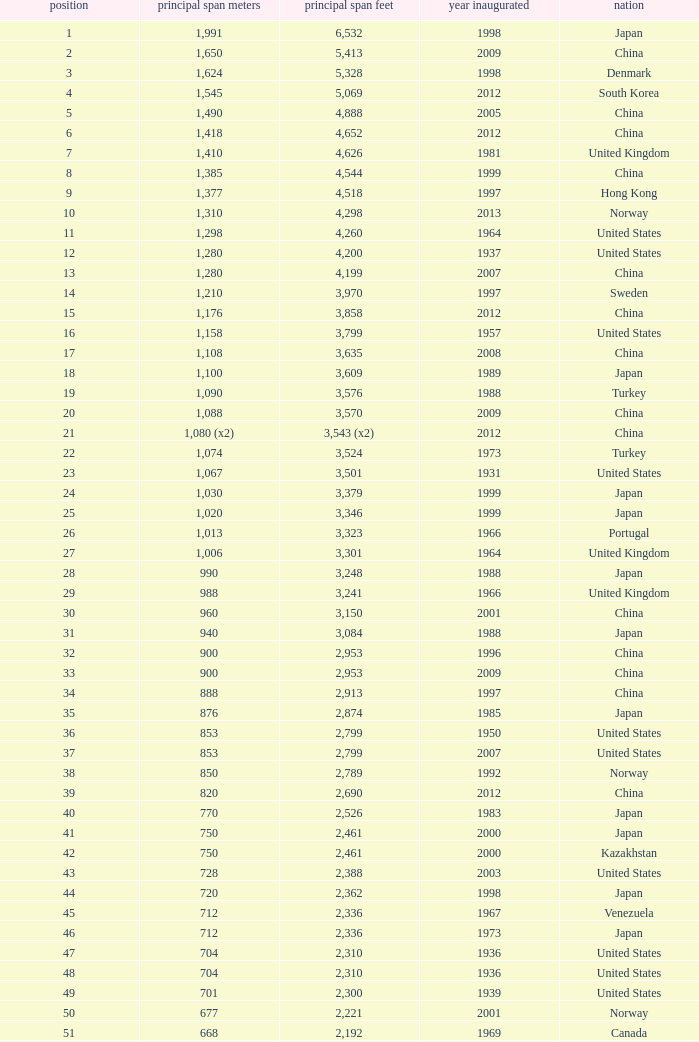What is the main span feet from opening year of 1936 in the United States with a rank greater than 47 and 421 main span metres? 1381.0. 